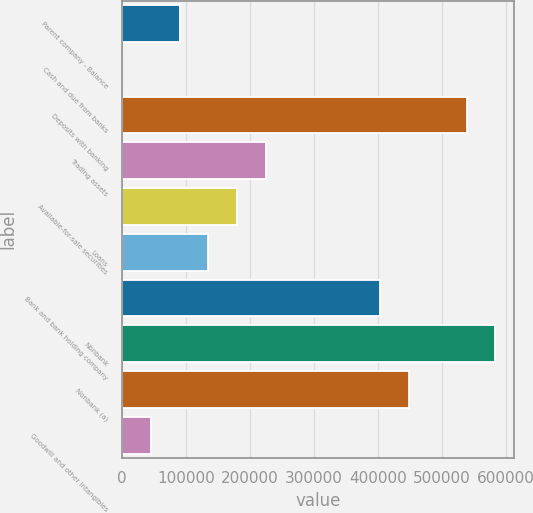<chart> <loc_0><loc_0><loc_500><loc_500><bar_chart><fcel>Parent company - Balance<fcel>Cash and due from banks<fcel>Deposits with banking<fcel>Trading assets<fcel>Available-for-sale securities<fcel>Loans<fcel>Bank and bank holding company<fcel>Nonbank<fcel>Nonbank (a)<fcel>Goodwill and other intangibles<nl><fcel>90025.6<fcel>216<fcel>539074<fcel>224740<fcel>179835<fcel>134930<fcel>404359<fcel>583978<fcel>449264<fcel>45120.8<nl></chart> 